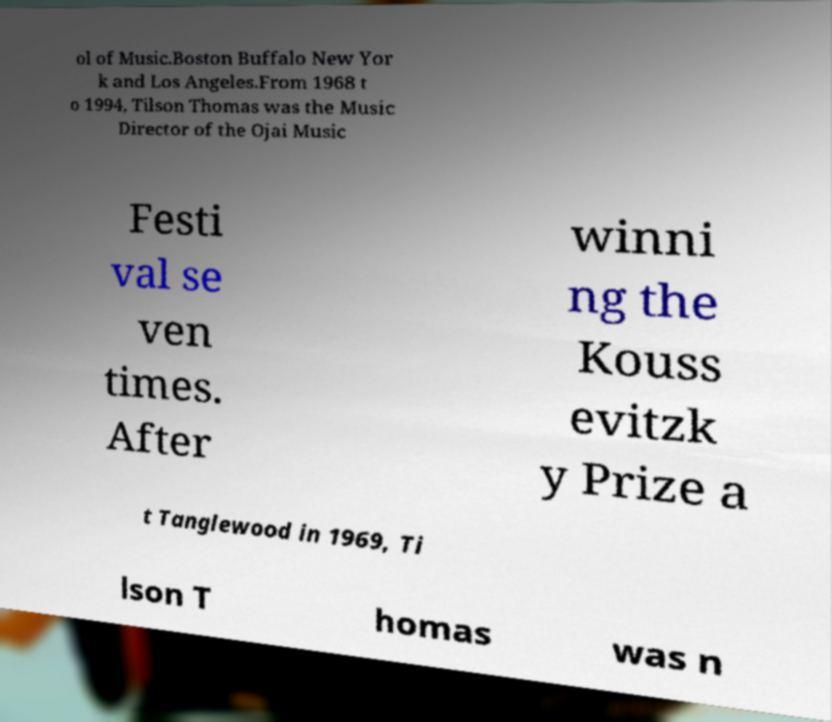There's text embedded in this image that I need extracted. Can you transcribe it verbatim? ol of Music.Boston Buffalo New Yor k and Los Angeles.From 1968 t o 1994, Tilson Thomas was the Music Director of the Ojai Music Festi val se ven times. After winni ng the Kouss evitzk y Prize a t Tanglewood in 1969, Ti lson T homas was n 